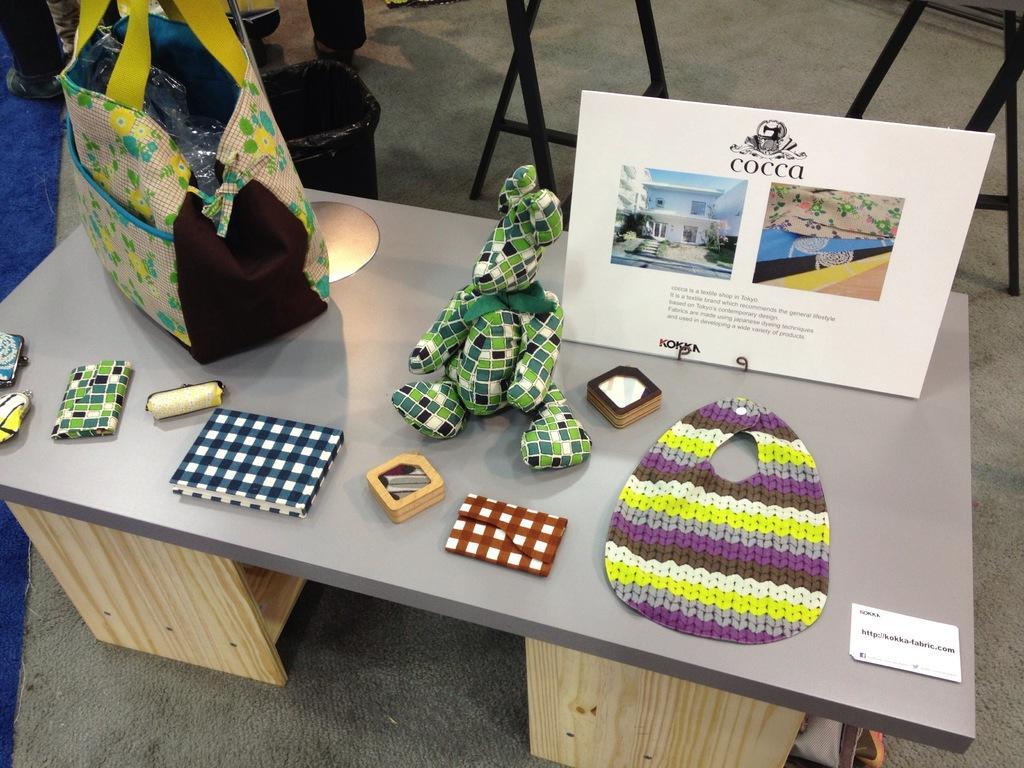In one or two sentences, can you explain what this image depicts? Here there is a wooden table. On the wooden table there are some frames, bags, toys, wallet, book and other objects. Behind the table there is a black color dustbin. 